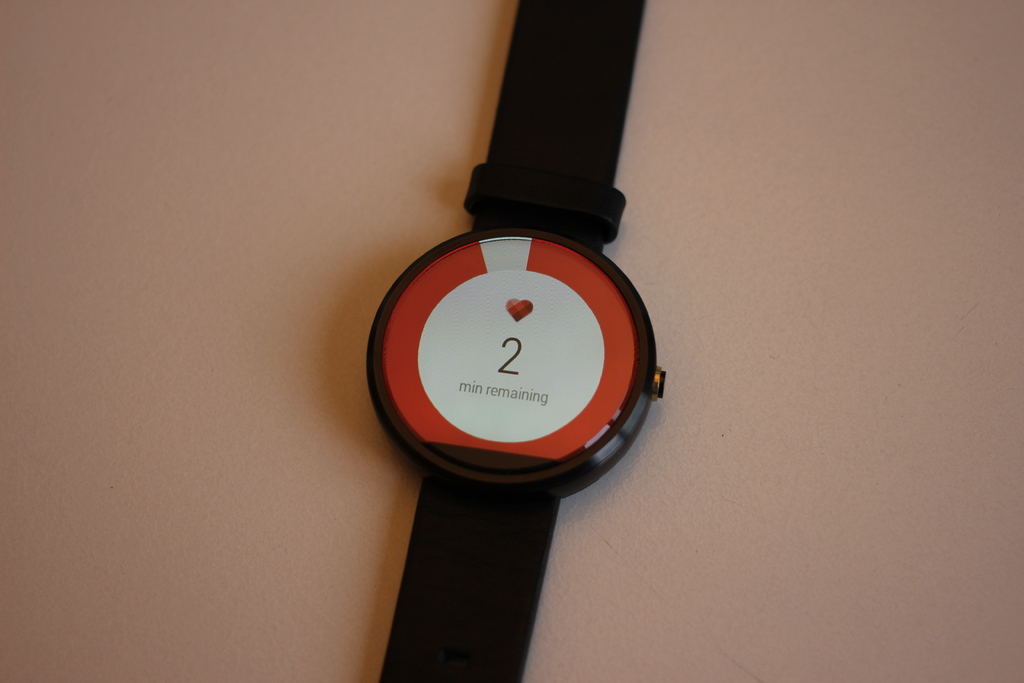What features might be highlighted on the smartwatch screen besides the time and heart symbol? Additional features might include fitness tracking metrics like steps and calorie count, notifications for messages or calls, and possibly customization options for the watch face. 